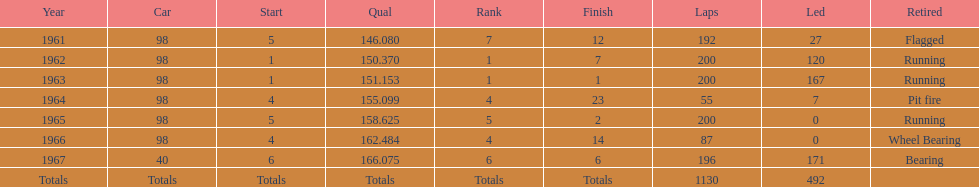In how many continuous years was parnelli positioned in the top 5? 5. 